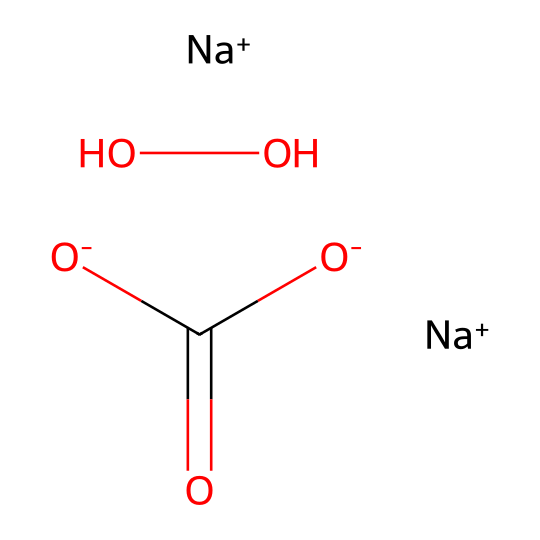How many sodium atoms are present in sodium percarbonate? The SMILES representation shows two instances of "[Na+]", indicating the presence of two sodium atoms in the compound.
Answer: 2 What is the total number of oxygen atoms in sodium percarbonate? Analyzing the SMILES, there are four oxygen atoms: two from the "OO" (peroxide group) and two from the "C(=O)[O-]" (carbonate part).
Answer: 4 What type of chemical bond connects the carbonate and peroxide groups in sodium percarbonate? The connection between the carbonate and peroxide groups involves single covalent bonds, as seen in the rendering of the structure with no indication of double bonds in that region.
Answer: single covalent bonds How many negative charges are present in sodium percarbonate? The structure shows two "O-" (negative charges) from the carbonate and one "O-" from the peroxide, giving a total of three negative charges.
Answer: 3 What is the primary role of sodium percarbonate in laundry detergents? Sodium percarbonate acts as an oxygen-releasing compound, which breaks down into hydrogen peroxide upon dissolution in water, providing bleaching and disinfecting properties.
Answer: bleaching agent Which part of the sodium percarbonate structure makes it an oxidizer? The peroxide group (OO) in the structure is responsible for its oxidizing ability, as it can release oxygen when it decomposes.
Answer: peroxide group What is the significance of the carbonate group in sodium percarbonate? The carbonate group provides stability and allows the compound to release hydrogen peroxide effectively when dissolved, enhancing its cleansing action.
Answer: stability and release agent 